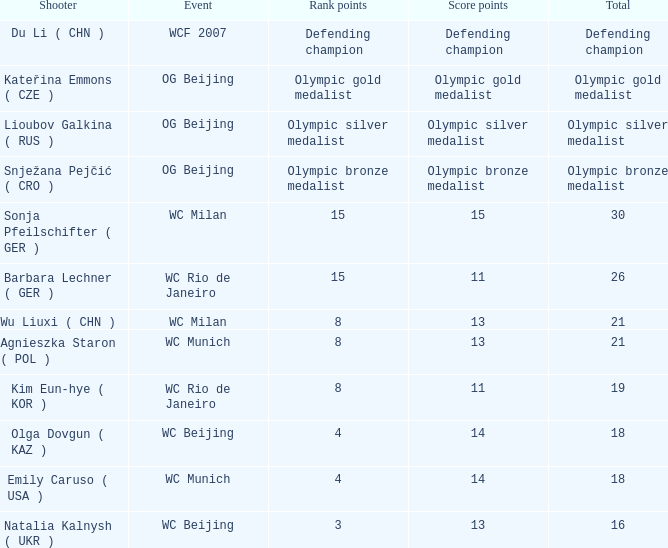Which event had a total of defending champion? WCF 2007. 